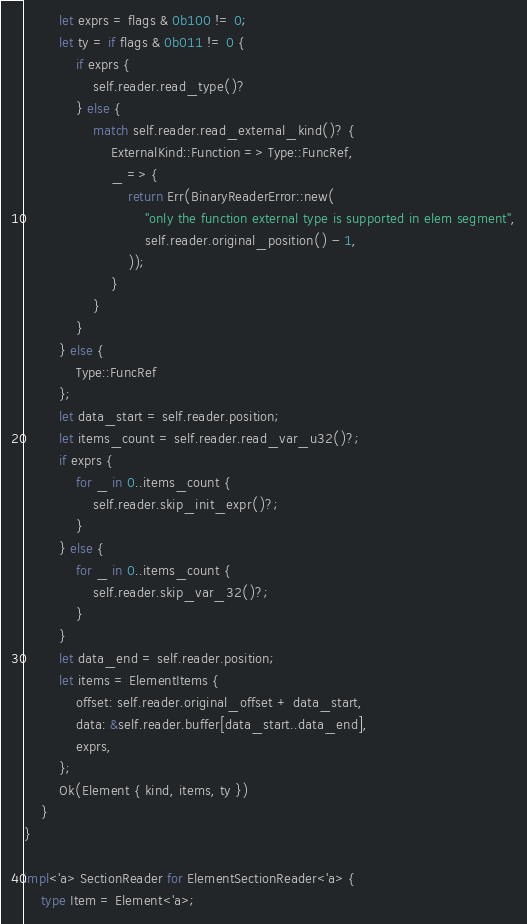<code> <loc_0><loc_0><loc_500><loc_500><_Rust_>        let exprs = flags & 0b100 != 0;
        let ty = if flags & 0b011 != 0 {
            if exprs {
                self.reader.read_type()?
            } else {
                match self.reader.read_external_kind()? {
                    ExternalKind::Function => Type::FuncRef,
                    _ => {
                        return Err(BinaryReaderError::new(
                            "only the function external type is supported in elem segment",
                            self.reader.original_position() - 1,
                        ));
                    }
                }
            }
        } else {
            Type::FuncRef
        };
        let data_start = self.reader.position;
        let items_count = self.reader.read_var_u32()?;
        if exprs {
            for _ in 0..items_count {
                self.reader.skip_init_expr()?;
            }
        } else {
            for _ in 0..items_count {
                self.reader.skip_var_32()?;
            }
        }
        let data_end = self.reader.position;
        let items = ElementItems {
            offset: self.reader.original_offset + data_start,
            data: &self.reader.buffer[data_start..data_end],
            exprs,
        };
        Ok(Element { kind, items, ty })
    }
}

impl<'a> SectionReader for ElementSectionReader<'a> {
    type Item = Element<'a>;</code> 